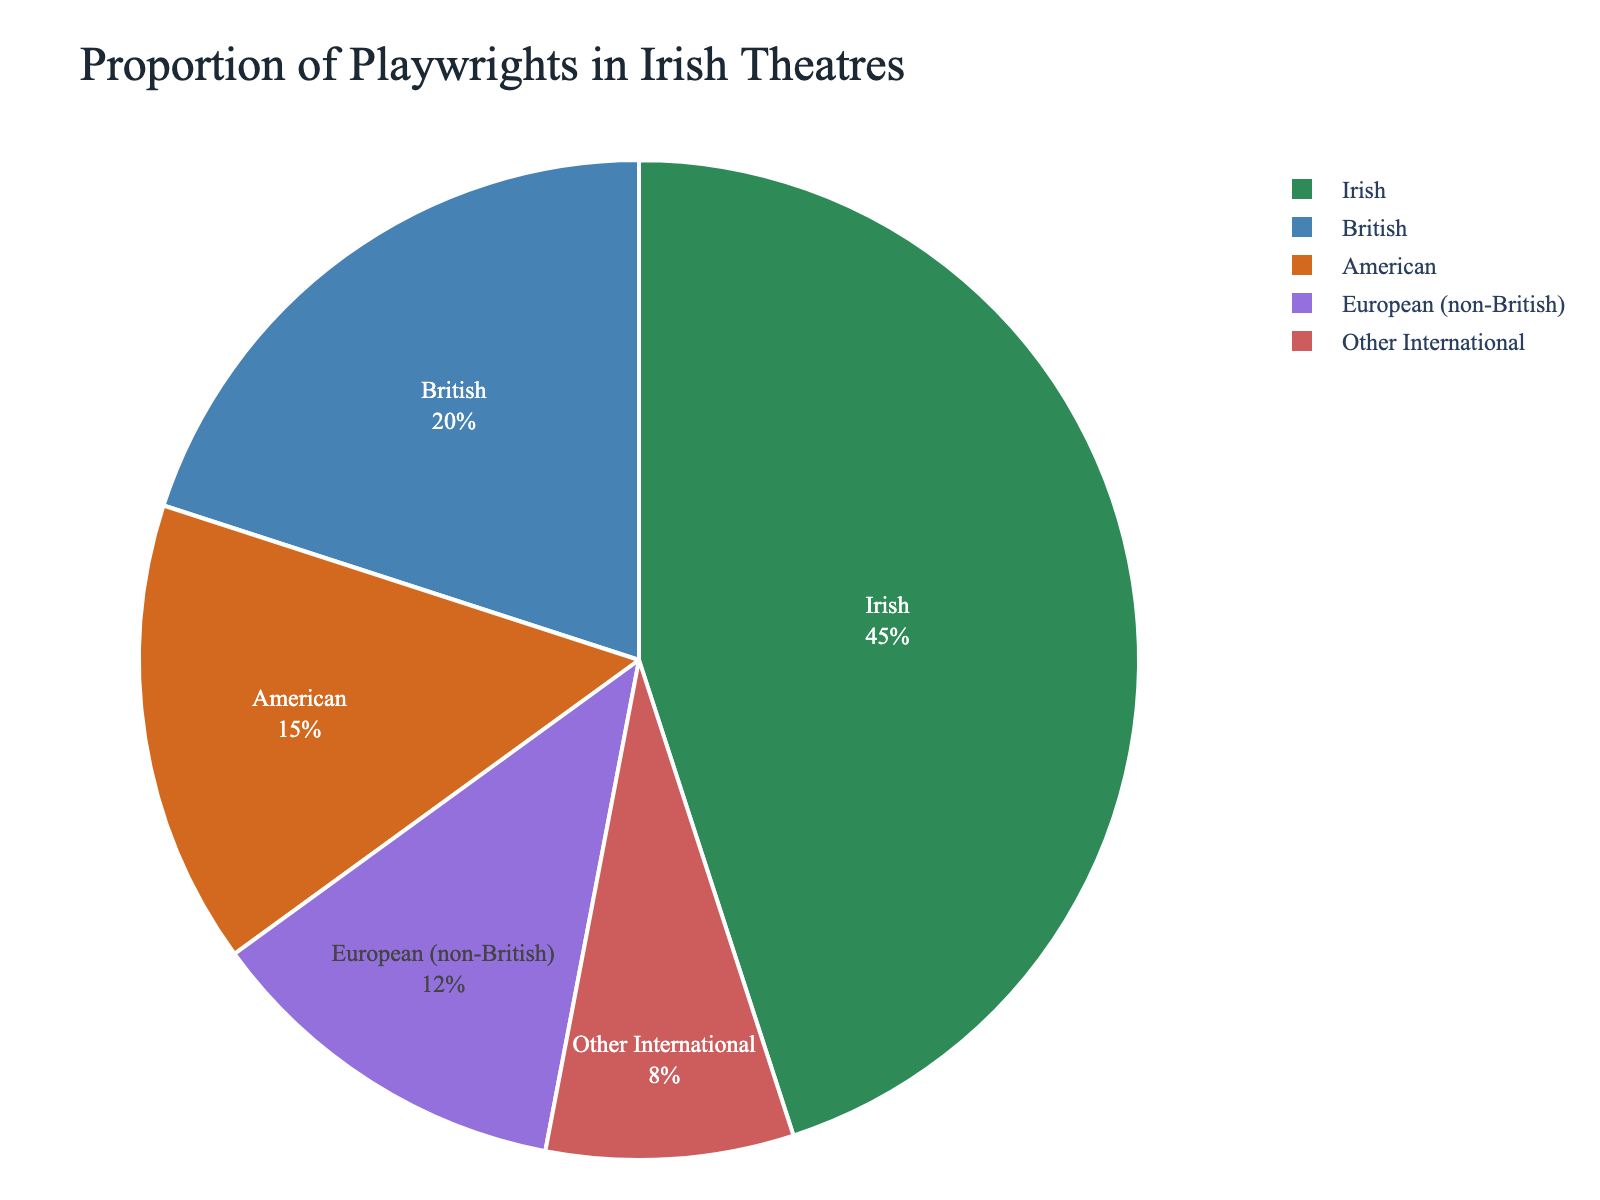What percentage of playwrights featured in Irish theatres are not from Ireland? The chart shows that 45% of the playwrights are Irish. To find the percentage of non-Irish playwrights, subtract the Irish percentage from 100%. 100% - 45% = 55%
Answer: 55% Which non-Irish group has the highest proportion of playwrights? The chart shows different segments for non-Irish playwrights: British (20%), American (15%), European (non-British) (12%), and Other International (8%). The British segment has the highest proportion among non-Irish playwrights.
Answer: British How does the proportion of American playwrights compare to European (non-British) playwrights? The chart shows that the percentage of American playwrights is 15% and European (non-British) playwrights is 12%. 15% is greater than 12%.
Answer: American playwrights have a higher proportion What is the combined percentage of British and American playwrights in Irish theatres? The chart indicates that British playwrights are 20% and American playwrights are 15%. Adding these percentages gives 20% + 15% = 35%.
Answer: 35% What color represents the "Other International" playwrights in the pie chart? The chart's color scheme uses specific colors for different segments. "Other International" is represented by the last color in the custom palette. Visually, this segment is shown in red.
Answer: Red How much larger is the proportion of Irish playwrights compared to European (non-British) playwrights? The chart shows that Irish playwrights constitute 45% and European (non-British) playwrights constitute 12%. The difference is 45% - 12% = 33%.
Answer: 33% What is the sum of the percentages of Irish and European (non-British) playwrights? The chart shows that Irish playwrights are 45% and European (non-British) playwrights are 12%. The sum is 45% + 12% = 57%.
Answer: 57% Which playwright group has the smallest representation in Irish theatres? The chart indicates that the "Other International" segment has only 8%, which is the smallest percentage among all segments.
Answer: Other International 